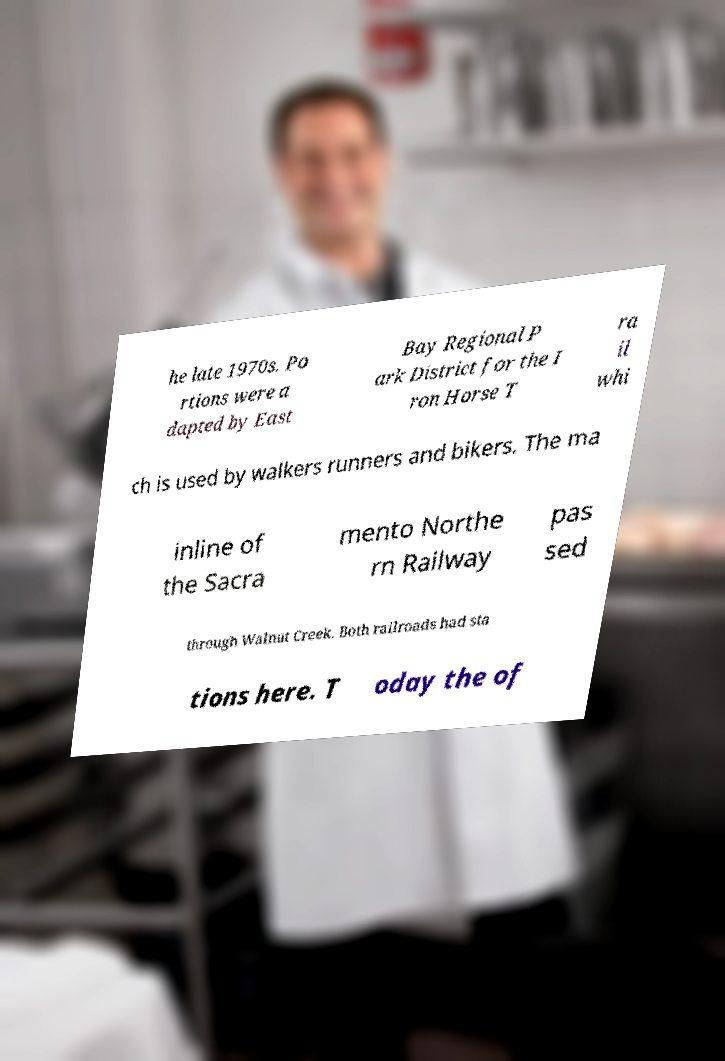For documentation purposes, I need the text within this image transcribed. Could you provide that? he late 1970s. Po rtions were a dapted by East Bay Regional P ark District for the I ron Horse T ra il whi ch is used by walkers runners and bikers. The ma inline of the Sacra mento Northe rn Railway pas sed through Walnut Creek. Both railroads had sta tions here. T oday the of 